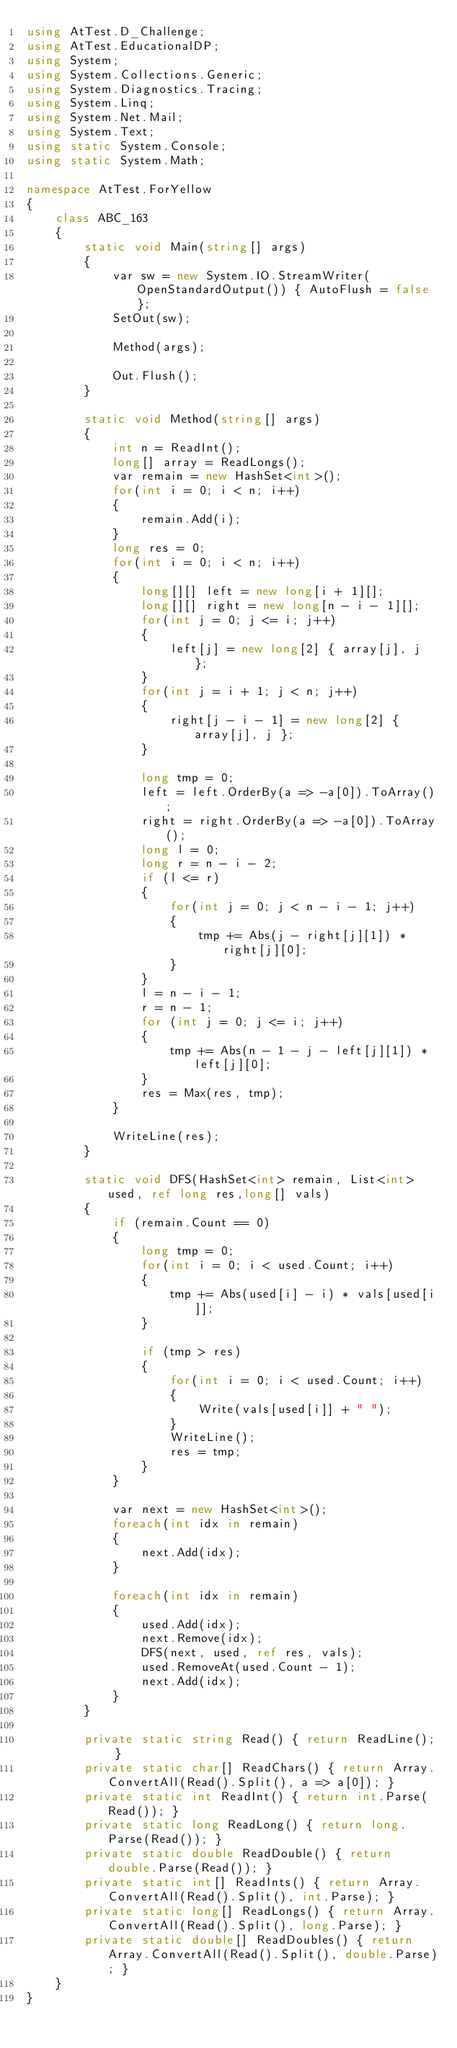<code> <loc_0><loc_0><loc_500><loc_500><_C#_>using AtTest.D_Challenge;
using AtTest.EducationalDP;
using System;
using System.Collections.Generic;
using System.Diagnostics.Tracing;
using System.Linq;
using System.Net.Mail;
using System.Text;
using static System.Console;
using static System.Math;

namespace AtTest.ForYellow
{
    class ABC_163
    {
        static void Main(string[] args)
        {
            var sw = new System.IO.StreamWriter(OpenStandardOutput()) { AutoFlush = false };
            SetOut(sw);

            Method(args);

            Out.Flush();
        }

        static void Method(string[] args)
        {
            int n = ReadInt();
            long[] array = ReadLongs();
            var remain = new HashSet<int>();
            for(int i = 0; i < n; i++)
            {
                remain.Add(i);
            }
            long res = 0;
            for(int i = 0; i < n; i++)
            {
                long[][] left = new long[i + 1][];
                long[][] right = new long[n - i - 1][];
                for(int j = 0; j <= i; j++)
                {
                    left[j] = new long[2] { array[j], j };
                }
                for(int j = i + 1; j < n; j++)
                {
                    right[j - i - 1] = new long[2] { array[j], j };
                }

                long tmp = 0;
                left = left.OrderBy(a => -a[0]).ToArray();
                right = right.OrderBy(a => -a[0]).ToArray();
                long l = 0;
                long r = n - i - 2;
                if (l <= r)
                {
                    for(int j = 0; j < n - i - 1; j++)
                    {
                        tmp += Abs(j - right[j][1]) * right[j][0];
                    }
                }
                l = n - i - 1;
                r = n - 1;
                for (int j = 0; j <= i; j++)
                {
                    tmp += Abs(n - 1 - j - left[j][1]) * left[j][0];
                }
                res = Max(res, tmp);
            }

            WriteLine(res);
        }

        static void DFS(HashSet<int> remain, List<int> used, ref long res,long[] vals)
        {
            if (remain.Count == 0)
            {
                long tmp = 0;
                for(int i = 0; i < used.Count; i++)
                {
                    tmp += Abs(used[i] - i) * vals[used[i]];
                }

                if (tmp > res)
                {
                    for(int i = 0; i < used.Count; i++)
                    {
                        Write(vals[used[i]] + " ");
                    }
                    WriteLine();
                    res = tmp;
                }
            }

            var next = new HashSet<int>();
            foreach(int idx in remain)
            {
                next.Add(idx);
            }

            foreach(int idx in remain)
            {
                used.Add(idx);
                next.Remove(idx);
                DFS(next, used, ref res, vals);
                used.RemoveAt(used.Count - 1);
                next.Add(idx);
            }
        }

        private static string Read() { return ReadLine(); }
        private static char[] ReadChars() { return Array.ConvertAll(Read().Split(), a => a[0]); }
        private static int ReadInt() { return int.Parse(Read()); }
        private static long ReadLong() { return long.Parse(Read()); }
        private static double ReadDouble() { return double.Parse(Read()); }
        private static int[] ReadInts() { return Array.ConvertAll(Read().Split(), int.Parse); }
        private static long[] ReadLongs() { return Array.ConvertAll(Read().Split(), long.Parse); }
        private static double[] ReadDoubles() { return Array.ConvertAll(Read().Split(), double.Parse); }
    }
}
</code> 